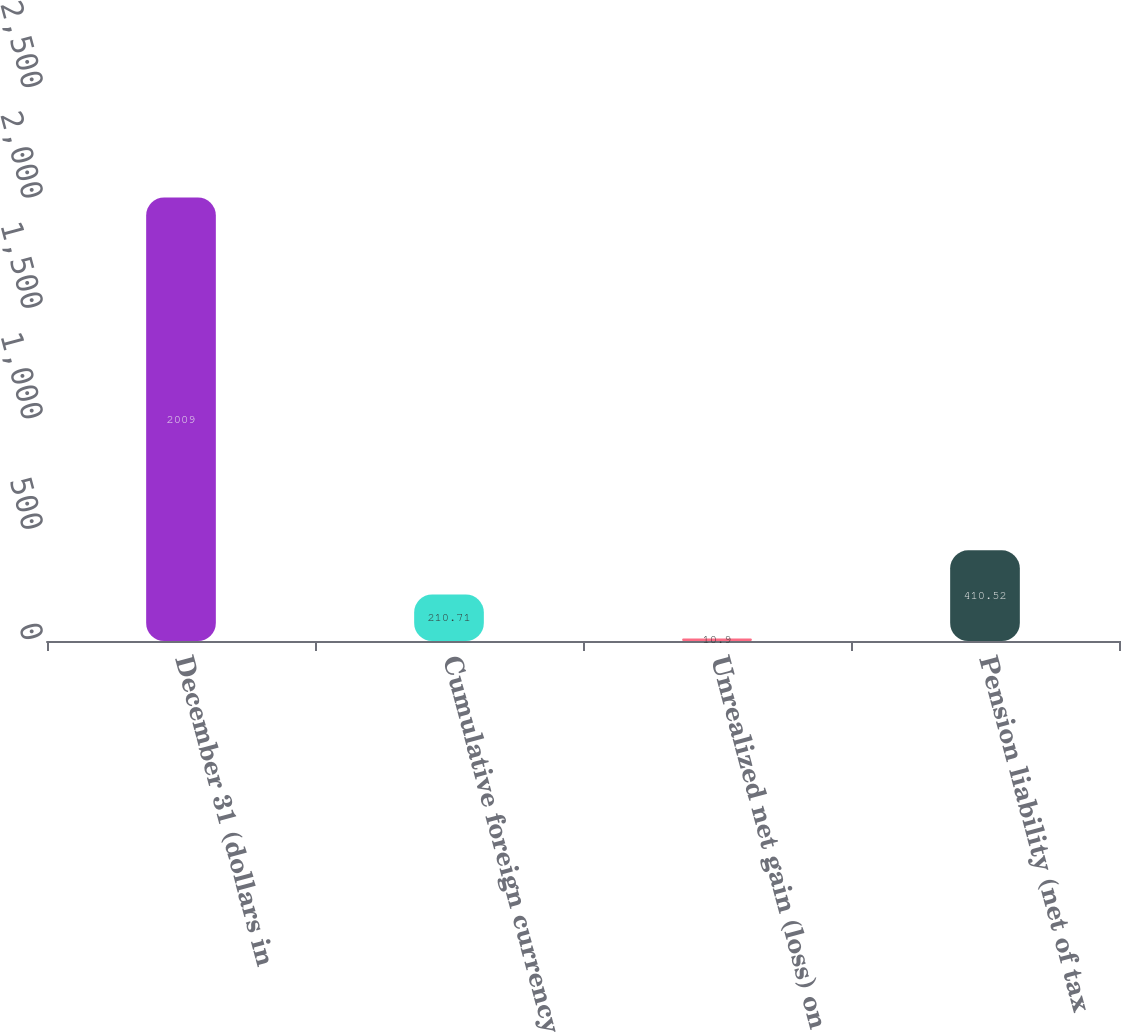Convert chart to OTSL. <chart><loc_0><loc_0><loc_500><loc_500><bar_chart><fcel>December 31 (dollars in<fcel>Cumulative foreign currency<fcel>Unrealized net gain (loss) on<fcel>Pension liability (net of tax<nl><fcel>2009<fcel>210.71<fcel>10.9<fcel>410.52<nl></chart> 